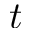Convert formula to latex. <formula><loc_0><loc_0><loc_500><loc_500>t</formula> 